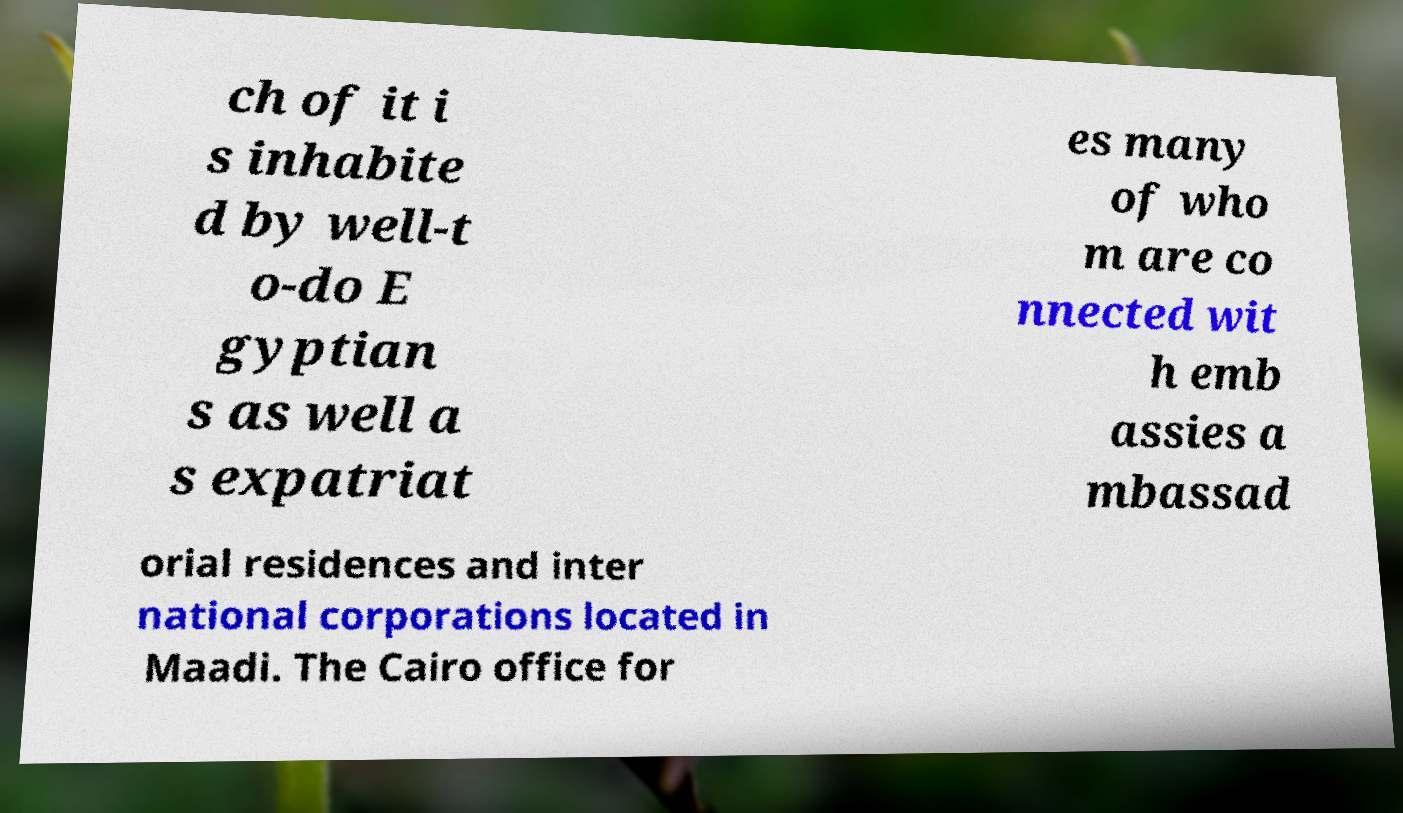Please identify and transcribe the text found in this image. ch of it i s inhabite d by well-t o-do E gyptian s as well a s expatriat es many of who m are co nnected wit h emb assies a mbassad orial residences and inter national corporations located in Maadi. The Cairo office for 